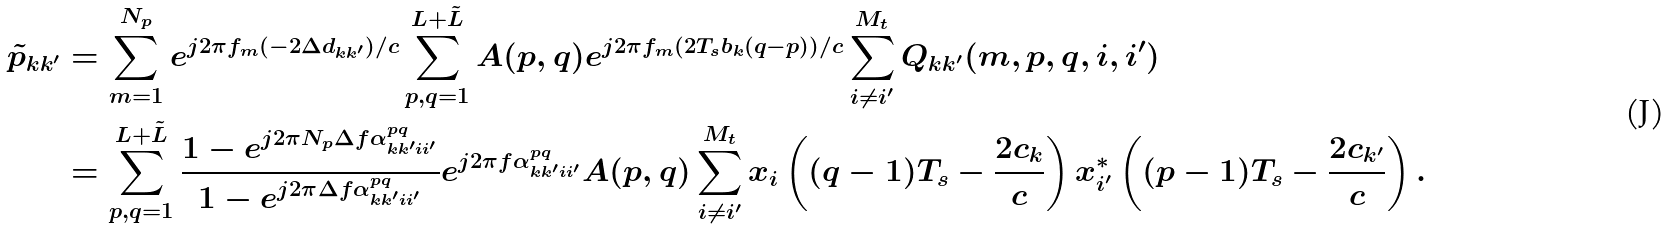Convert formula to latex. <formula><loc_0><loc_0><loc_500><loc_500>\tilde { p } _ { k k ^ { \prime } } & = \sum _ { m = 1 } ^ { N _ { p } } e ^ { j 2 \pi f _ { m } ( - 2 \Delta d _ { k k ^ { \prime } } ) / c } \sum _ { p , q = 1 } ^ { L + \tilde { L } } { A } ( p , q ) e ^ { j 2 \pi f _ { m } ( 2 T _ { s } b _ { k } ( q - p ) ) / c } \sum _ { i \neq i ^ { \prime } } ^ { M _ { t } } Q _ { k k ^ { \prime } } ( m , p , q , i , i ^ { \prime } ) \\ & = \sum _ { p , q = 1 } ^ { L + \tilde { L } } \frac { 1 - e ^ { j 2 \pi N _ { p } \Delta f \alpha _ { k k ^ { \prime } i i ^ { \prime } } ^ { p q } } } { 1 - e ^ { j 2 \pi \Delta f \alpha _ { k k ^ { \prime } i i ^ { \prime } } ^ { p q } } } e ^ { j 2 \pi f \alpha _ { k k ^ { \prime } i i ^ { \prime } } ^ { p q } } { A } ( p , q ) \sum _ { i \neq i ^ { \prime } } ^ { M _ { t } } x _ { i } \left ( ( q - 1 ) T _ { s } - \frac { 2 c _ { k } } { c } \right ) x ^ { * } _ { i ^ { \prime } } \left ( ( p - 1 ) T _ { s } - \frac { 2 c _ { k ^ { \prime } } } { c } \right ) .</formula> 